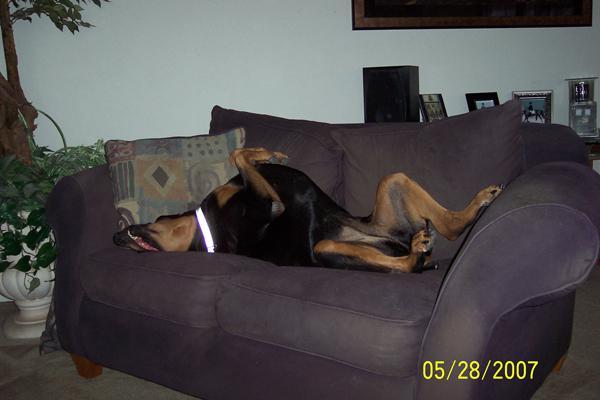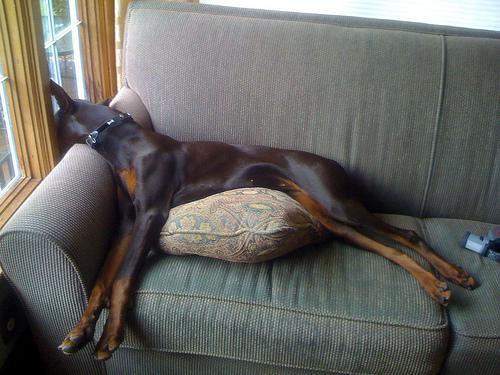The first image is the image on the left, the second image is the image on the right. Considering the images on both sides, is "The dog in each image is lying on a couch and is asleep." valid? Answer yes or no. Yes. 